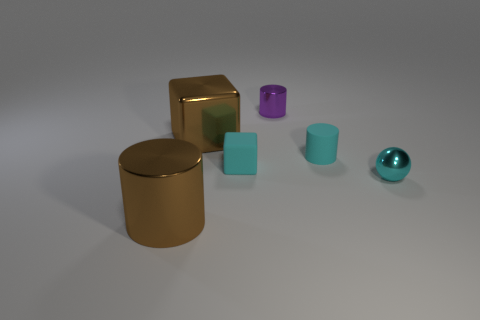What color is the metal cube?
Offer a very short reply. Brown. There is a cube that is the same color as the rubber cylinder; what is its material?
Your answer should be compact. Rubber. Are there any other large things that have the same shape as the cyan shiny object?
Your response must be concise. No. There is a metallic cylinder that is in front of the tiny purple cylinder; how big is it?
Give a very brief answer. Large. There is a thing that is the same size as the metal cube; what is its material?
Offer a very short reply. Metal. Are there more small spheres than green shiny objects?
Provide a short and direct response. Yes. There is a shiny cylinder that is in front of the metallic thing behind the large cube; what size is it?
Your response must be concise. Large. What is the shape of the purple object that is the same size as the cyan matte cylinder?
Your answer should be very brief. Cylinder. The large brown metal object to the left of the large brown thing that is behind the metallic cylinder that is in front of the tiny cyan cube is what shape?
Your answer should be very brief. Cylinder. Does the big thing that is in front of the small metal sphere have the same color as the metallic cylinder that is behind the small cyan metallic ball?
Give a very brief answer. No. 